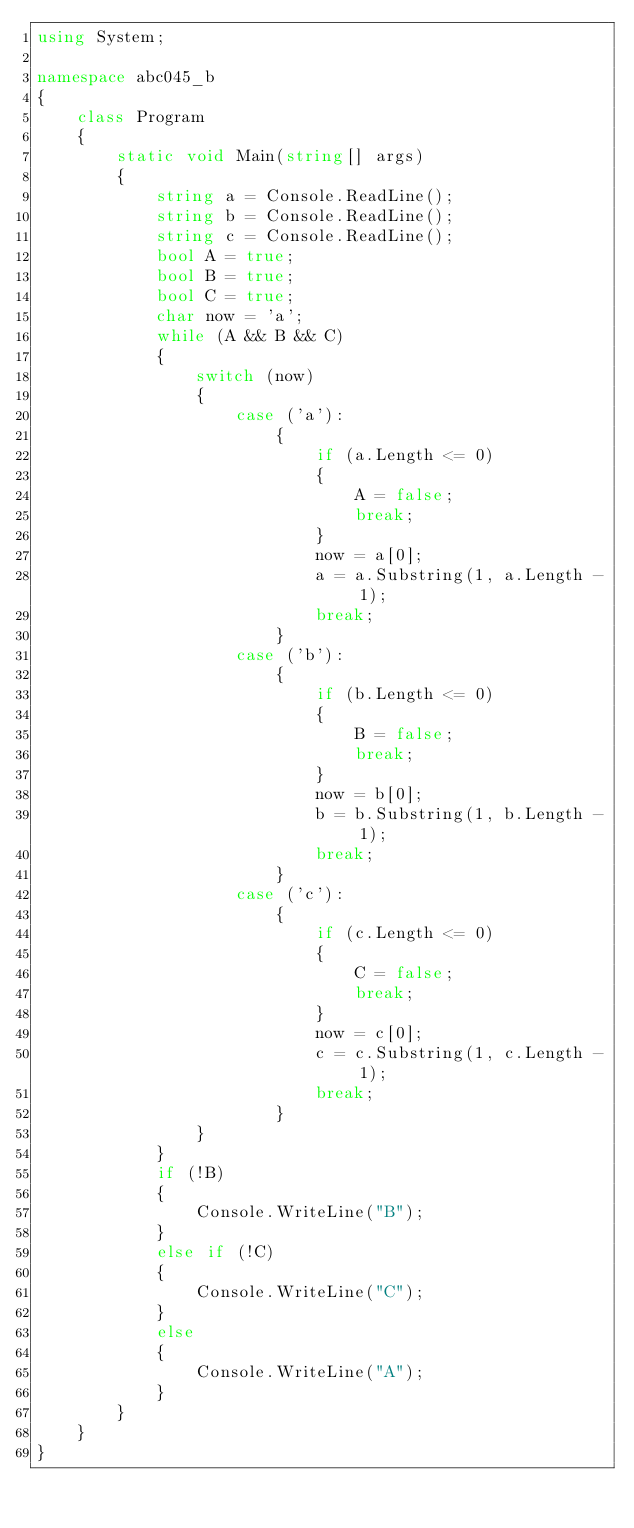<code> <loc_0><loc_0><loc_500><loc_500><_C#_>using System;

namespace abc045_b
{
    class Program
    {
        static void Main(string[] args)
        {
            string a = Console.ReadLine();
            string b = Console.ReadLine();
            string c = Console.ReadLine();
            bool A = true;
            bool B = true;
            bool C = true;
            char now = 'a';
            while (A && B && C)
            {
                switch (now)
                {
                    case ('a'):
                        {
                            if (a.Length <= 0)
                            {
                                A = false;
                                break;
                            }
                            now = a[0];
                            a = a.Substring(1, a.Length - 1);
                            break;
                        }
                    case ('b'):
                        {
                            if (b.Length <= 0)
                            {
                                B = false;
                                break;
                            }
                            now = b[0];
                            b = b.Substring(1, b.Length - 1);
                            break;
                        }
                    case ('c'):
                        {
                            if (c.Length <= 0)
                            {
                                C = false;
                                break;
                            }
                            now = c[0];
                            c = c.Substring(1, c.Length - 1);
                            break;
                        }
                }
            }
            if (!B)
            {
                Console.WriteLine("B");
            }
            else if (!C)
            {
                Console.WriteLine("C");
            }
            else
            {
                Console.WriteLine("A");
            }
        }
    }
}</code> 